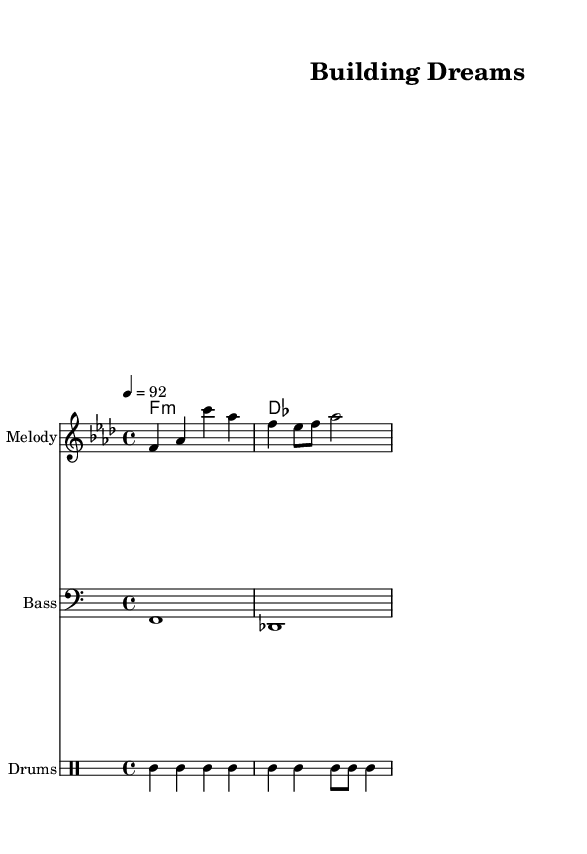What is the key signature of this music? The key signature is F minor, which indicates that it has four flats. This is determined by looking at the key signature section, where F minor has the flats B, E, A, and D.
Answer: F minor What is the time signature of this music? The time signature is 4/4, which means there are four beats in each measure, and the quarter note gets one beat. This can be identified from the time signature notation at the beginning of the sheet music.
Answer: 4/4 What is the tempo marking of the piece? The tempo is set at 92 beats per minute, as indicated in the tempo marking located in the global style section of the sheet music.
Answer: 92 How many beats are in the first measure? The first measure has four beats, as each quarter note in the time signature (4/4) represents one beat, and there are four quarter notes in the measure.
Answer: 4 What are the two main chords used in the harmony? The two chords are F minor and D flat major, as shown in the chord names section of the sheet music. These chords support the melody and provide harmonic structure.
Answer: F minor, D flat major What is the rhythmic pattern of the drums in the first four measures? The rhythmic pattern consists of a bass drum hit followed by hi-hat, repeating for four beats in a steady pattern, showcasing typical hip-hop drum rhythms. This can be seen in the drum staff sectional of the sheet music.
Answer: Bass, Hi-hat What lyrical theme is expressed in the song's lyrics? The lyrics express a theme of building and ambition, as evidenced by the line "Brick by brick, we're building high," reflecting the overall motivational message of the piece.
Answer: Building dreams 